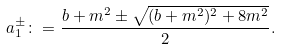Convert formula to latex. <formula><loc_0><loc_0><loc_500><loc_500>a _ { 1 } ^ { \pm } \colon = \frac { b + m ^ { 2 } \pm \sqrt { ( b + m ^ { 2 } ) ^ { 2 } + 8 m ^ { 2 } } } { 2 } .</formula> 